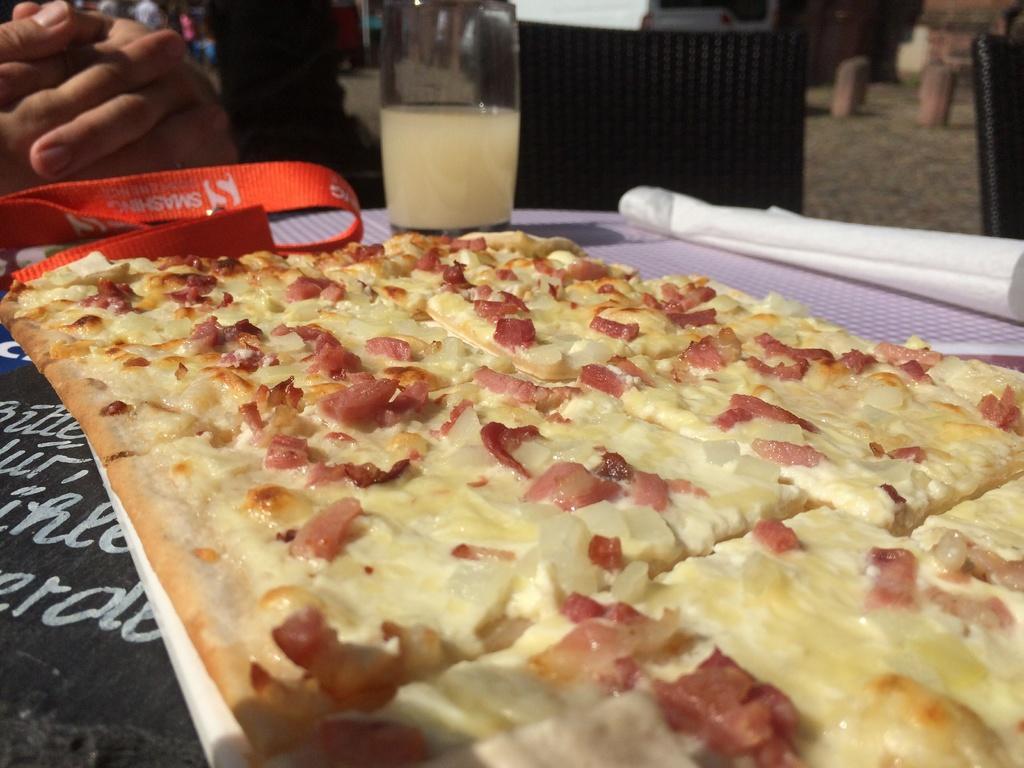Could you give a brief overview of what you see in this image? In this image we can see a food item, paper and a tag on a platform. In the background we can see person's hands on the left side, chairs and other objects. 